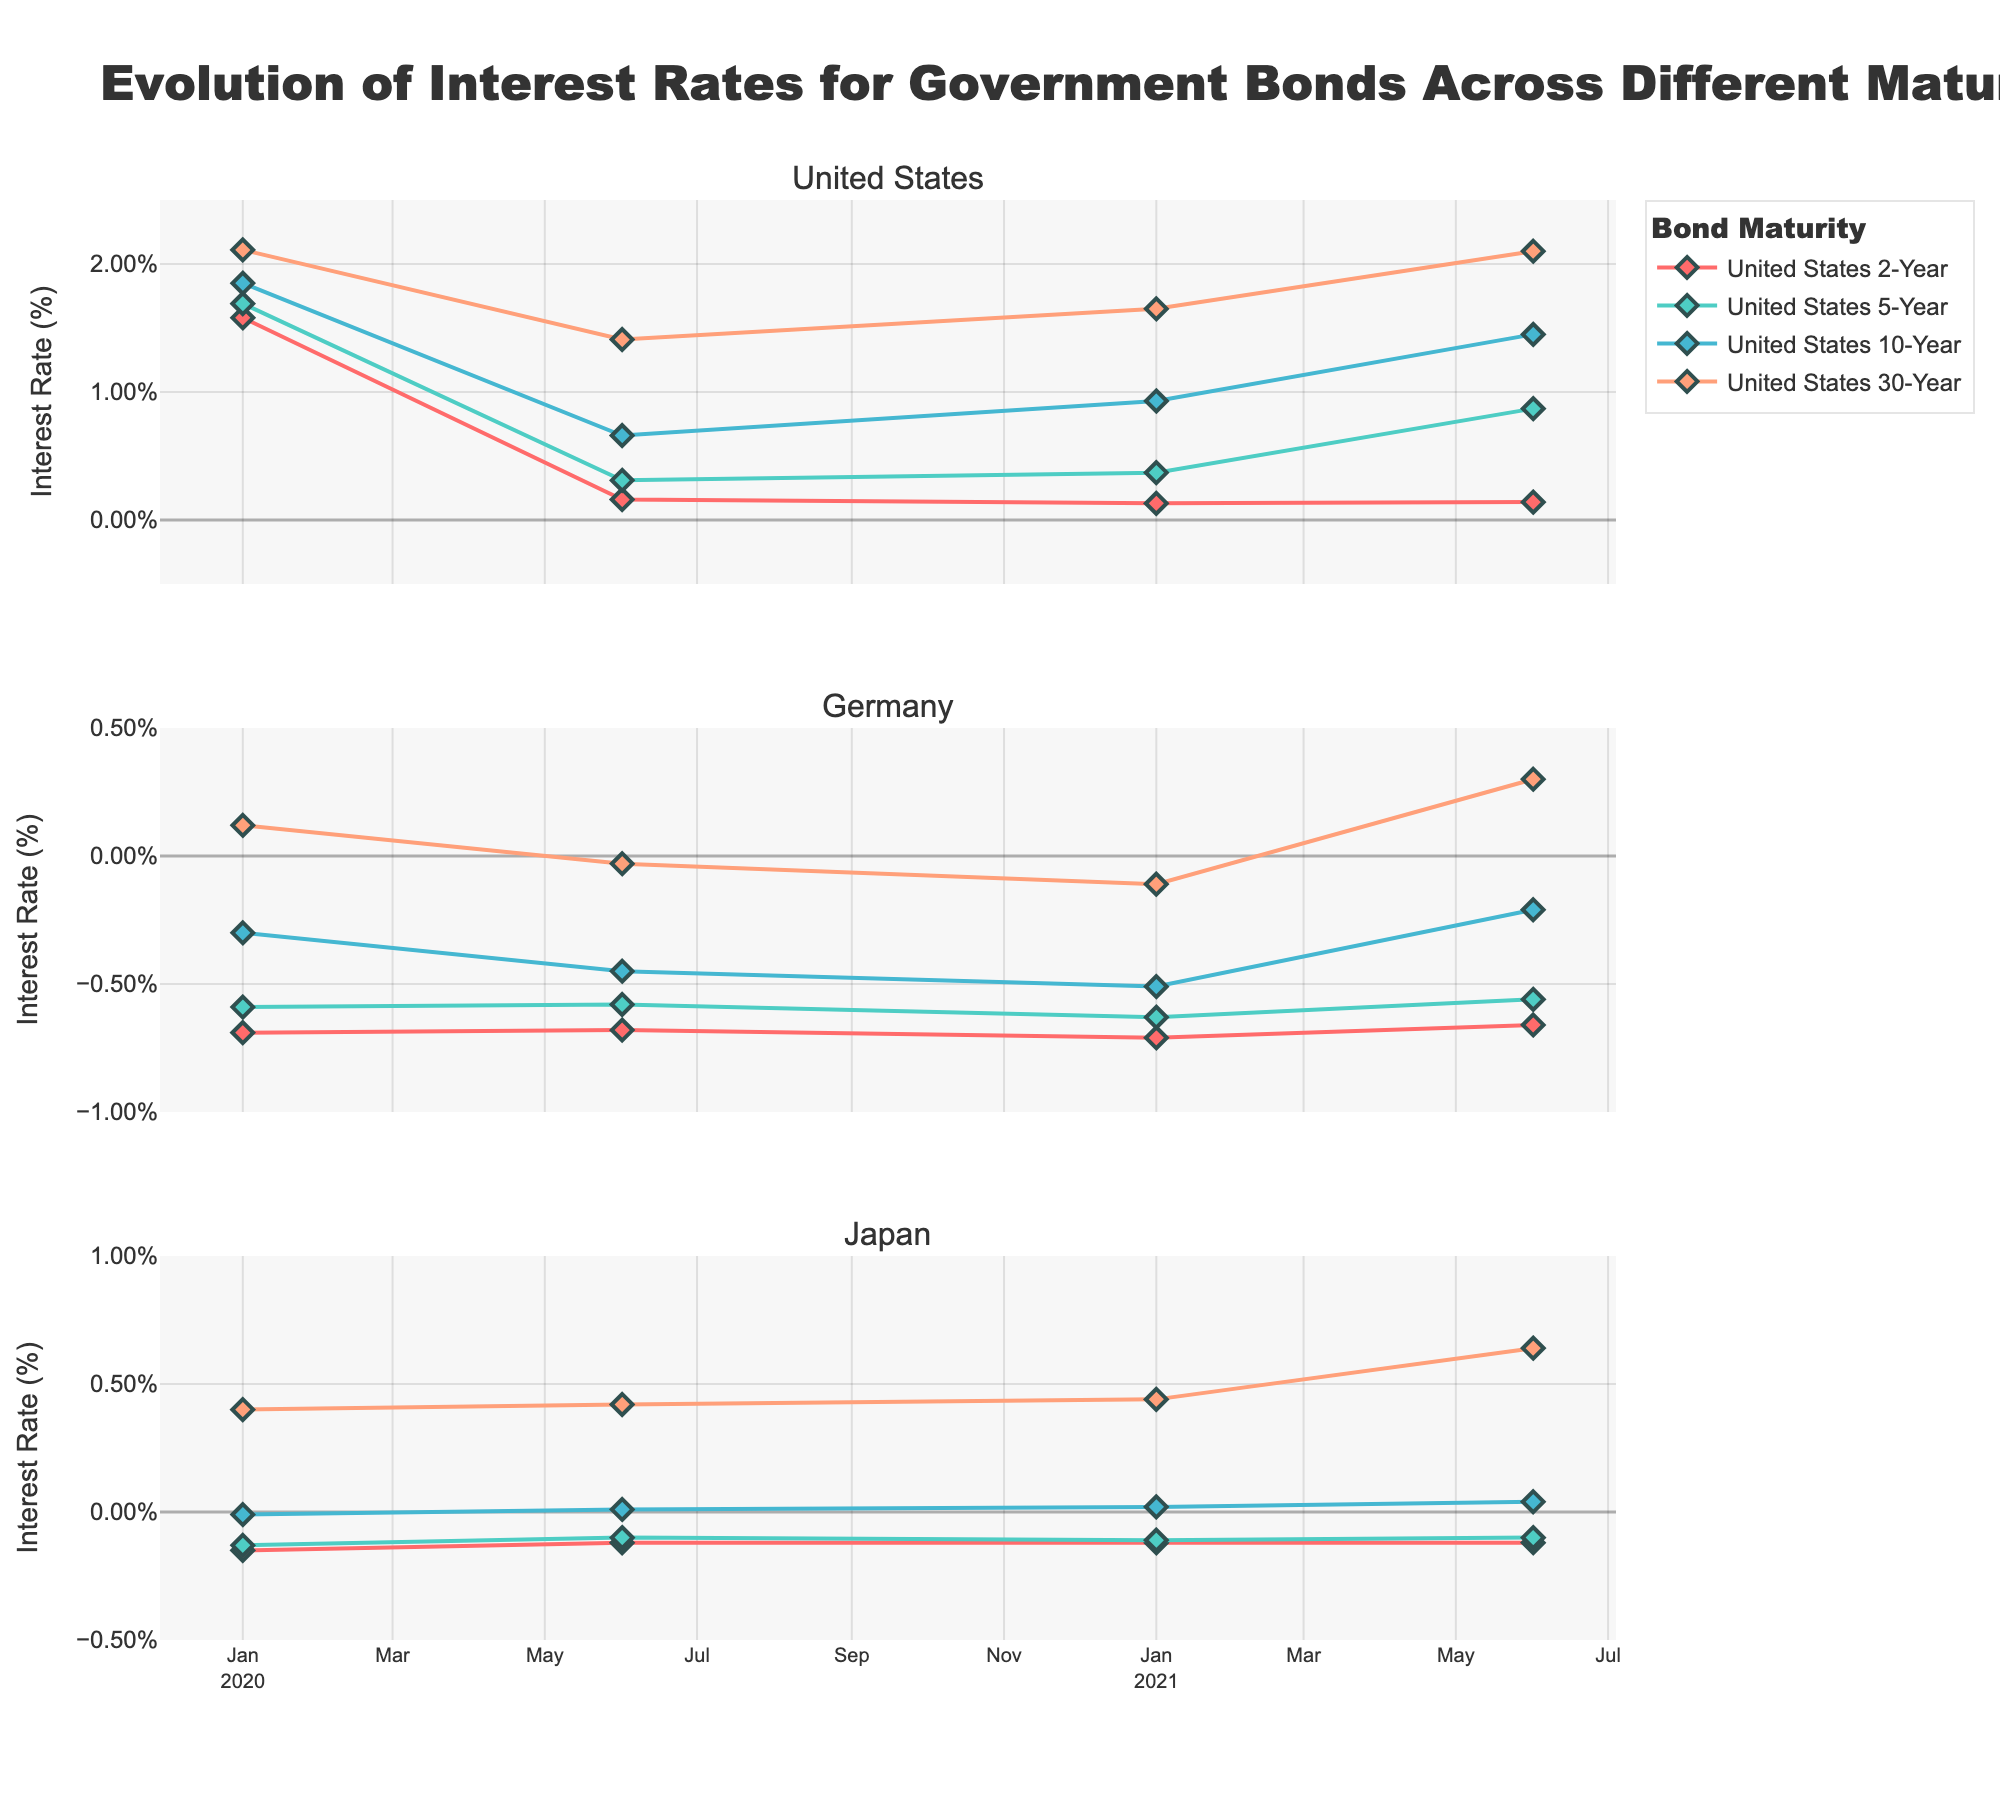What is the title of the figure? The title is shown at the top of the figure, indicating the main subject of the visualization.
Answer: Evolution of Interest Rates for Government Bonds Across Different Maturities How many subplots are there in the figure? There are three titles under the main title, suggesting there are three subplots, one for each country.
Answer: 3 Which country has the highest interest rate for the 30-Year bond on June 1, 2021? Examine the third data point for the 30-Year bond on June 1, 2021, in all three subplots. The United States has the highest rate at 2.10%.
Answer: United States What is the visual difference between the lines representing 2-Year and 10-Year bonds? The lines have different colors and markers. The 2-Year bond is represented with one color and the 10-Year bond with another; colors and symbols are specified in the legend.
Answer: The 2-Year bond line is red, and the 10-Year bond line is blue-green Which country's 10-Year bond interest rate turned positive in 2020? Check the 10-Year bond interest rate trend for each country. Only Japan's 10-Year bond crosses from negative to positive in 2020.
Answer: Japan Compare the trend of the 2-Year bond interest rate in the United States and Germany from January 2020 to June 2021. For the United States, the 2-Year bond interest rate drops from 1.58% to 0.14%. For Germany, it slightly decreases from -0.69% to -0.66%. This indicates a steeper decline in the United States.
Answer: The United States saw a steeper decline Which bond maturity shows an increasing trend in Japan from January 2020 to June 2021? The trend lines for each maturity in Japan should be examined. The 30-Year bond shows a consistent upward trend.
Answer: 30-Year What is the average interest rate for the 5-Year bond in Germany across all available dates? Sum the 5-Year bond rates in Germany: -0.59, -0.58, -0.63, -0.56. The average is (-0.59 - 0.58 - 0.63 - 0.56) / 4 = -0.59.
Answer: -0.59 Find the difference in the 10-Year bond interest rate in the United States between January 2020 and June 2021. The 10-Year bond rate in the United States on January 2020 is 1.85%, and on June 2021, it is 1.45%. Difference = 1.85% - 1.45% = 0.40%.
Answer: 0.40% Which country has consistently negative interest rates for the 2-Year bond throughout the given timeframe? Look at the 2-Year bond rates for all dates. Germany and Japan show negative values, but examination shows Japan's rates are consistently negative.
Answer: Japan 